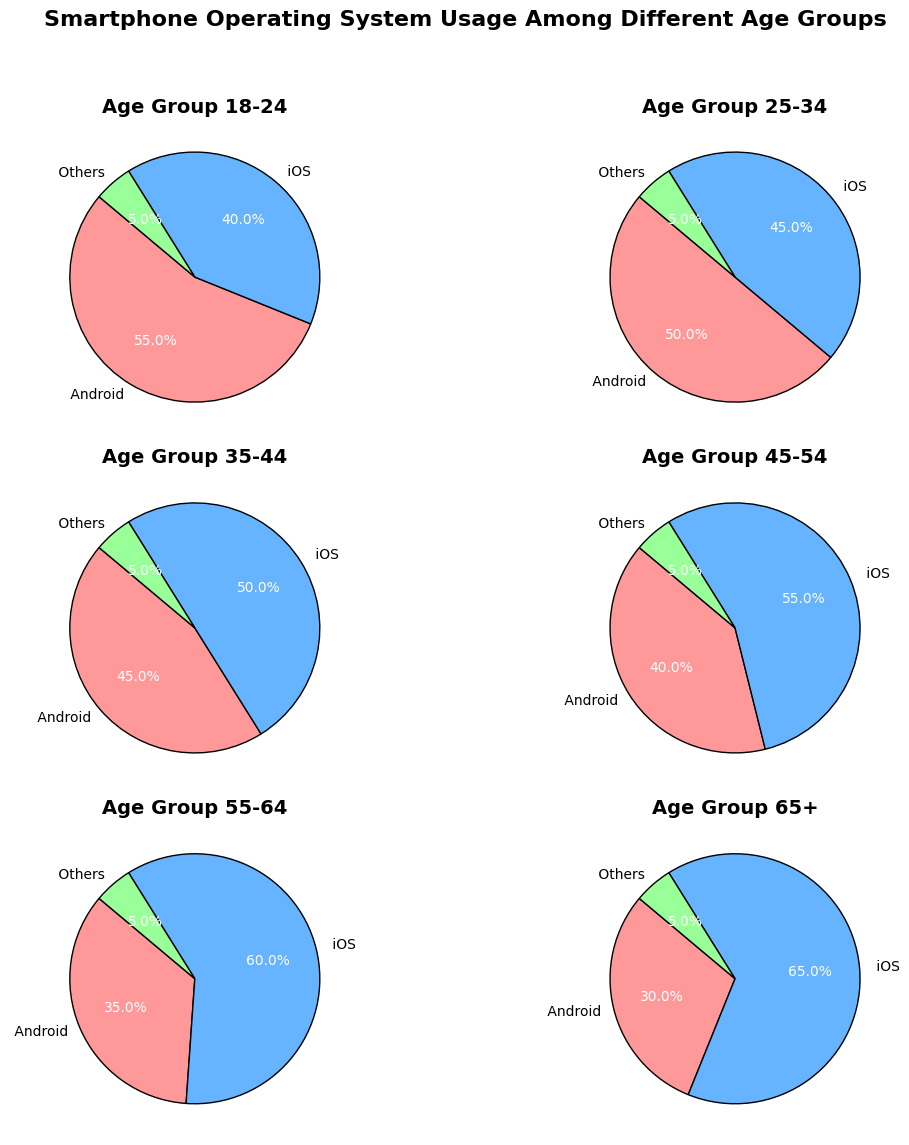Which age group has the highest percentage of iOS users? By examining each pie chart, the 65+ age group has the largest proportion dedicated to iOS usage compared to other age groups.
Answer: 65+ How does the percentage of Android users change from the 18-24 age group to the 65+ age group? The percentage of Android users decreases from 55% in the 18-24 age group to 30% in the 65+ age group.
Answer: Decreases For the 35-44 age group, what is the sum of the percentages for iOS and Others? For the 35-44 age group, iOS users are 50% and Others are 5%, so the sum is 50% + 5% = 55%.
Answer: 55% In which age group do iOS users surpass Android users by the largest margin? Comparing each pie chart, the 65+ age group shows the largest margin where iOS users (65%) surpass Android users (30%) by 35%.
Answer: 65+ Between the age groups 25-34 and 45-54, which has a higher percentage of Other OS users? Both groups have the same percentage of Other OS users, which is 5%.
Answer: Both Which age group has an equal percentage of iOS and Android users? The 35-44 age group has a nearly equal distribution, with 45% Android and 50% iOS users. While not exactly equal, it's the closest comparison.
Answer: 35-44 What is the average percentage of iOS users across all age groups? Sum the iOS percentages across all age groups (40 + 45 + 50 + 55 + 60 + 65) = 315 and divide by the number of age groups (6). The average percentage is 315 / 6 = 52.5%.
Answer: 52.5% Which age group shows the least variation among the three OS categories? The 18-24 and 25-34 age groups show lesser variations among Android, iOS, and Others but the variations seem slightly lesser for the 18-24 due to closer percentages of Android and iOS users.
Answer: 18-24 